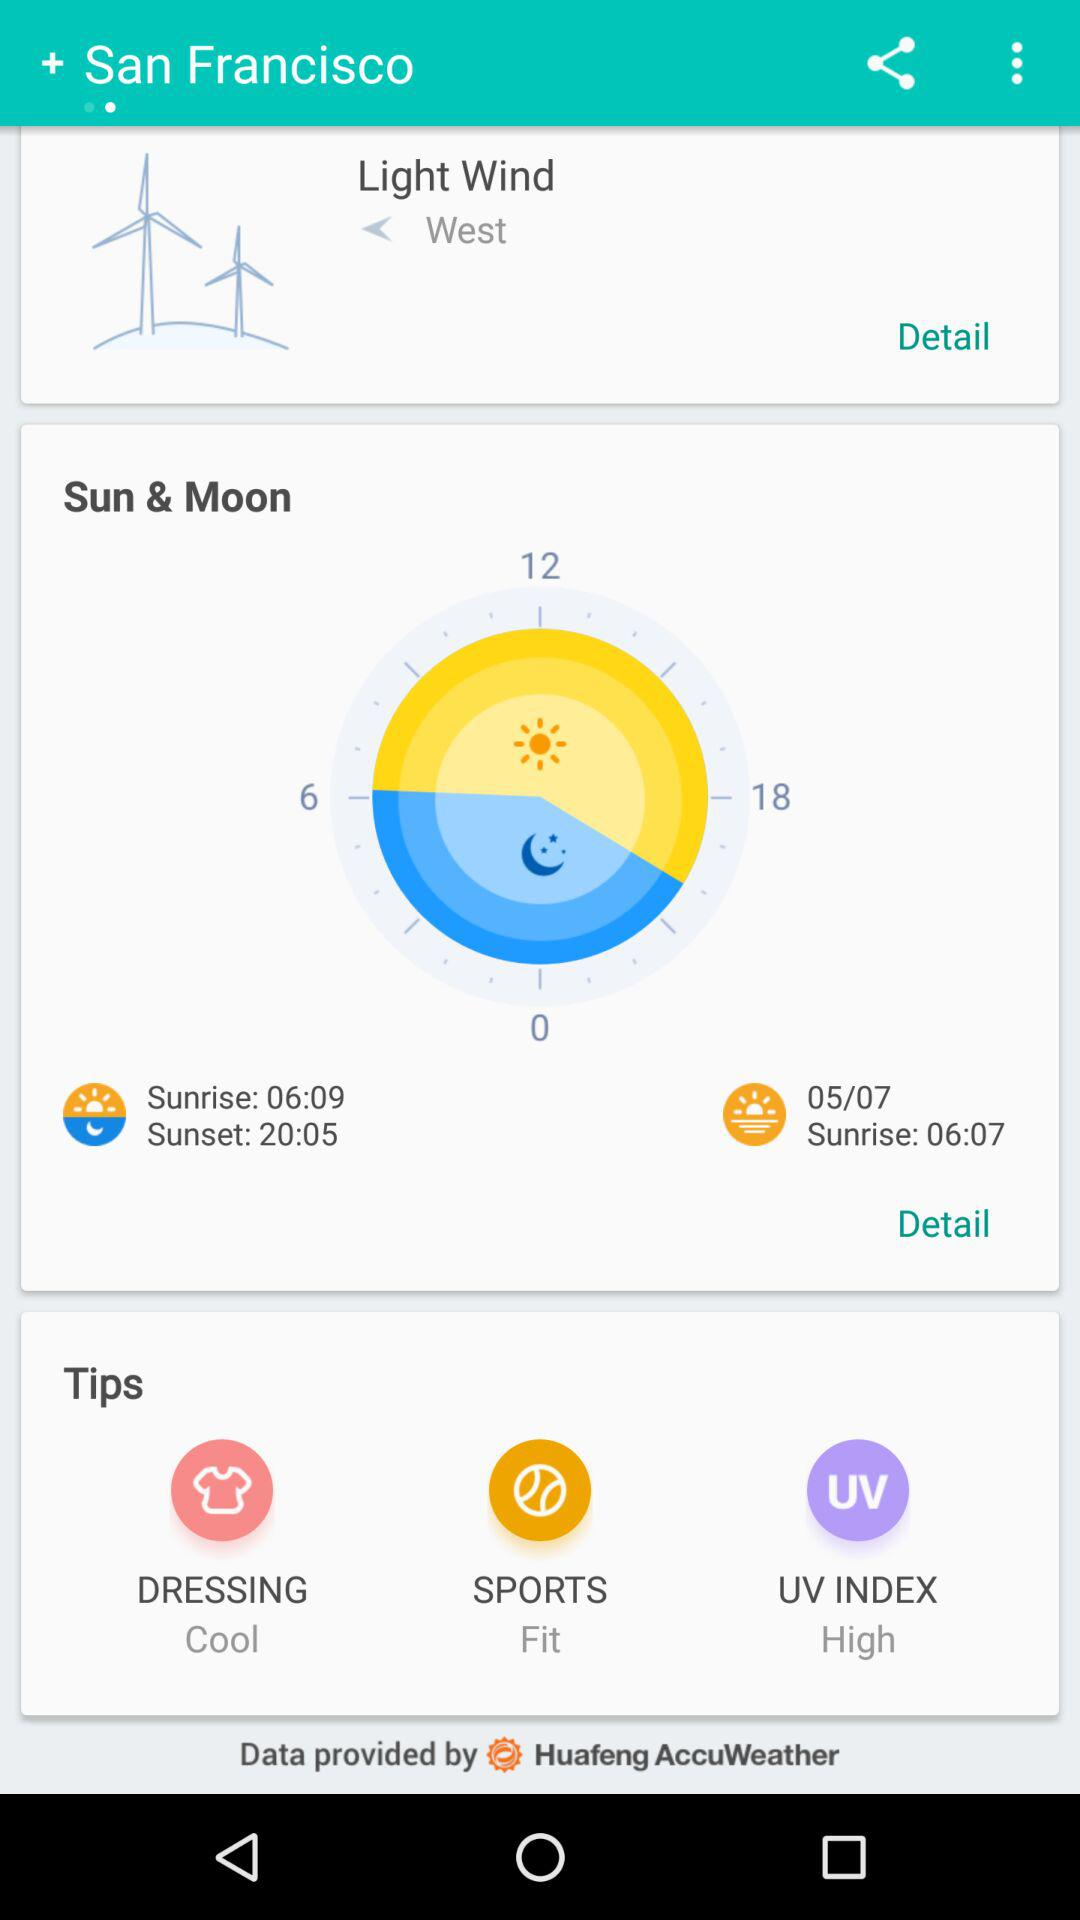What's the time for the sunrise on 05/07? The time is 06:07. 